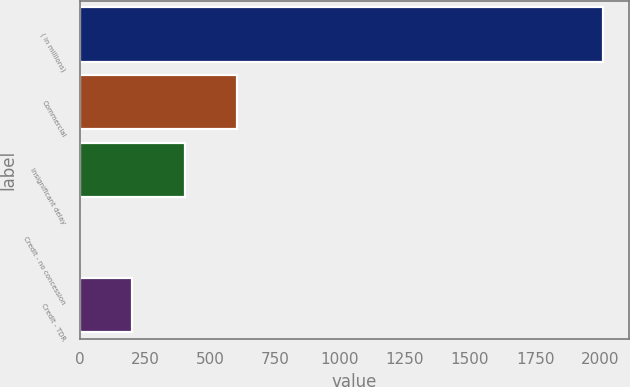Convert chart. <chart><loc_0><loc_0><loc_500><loc_500><bar_chart><fcel>( in millions)<fcel>Commercial<fcel>Insignificant delay<fcel>Credit - no concession<fcel>Credit - TDR<nl><fcel>2012<fcel>604.02<fcel>402.88<fcel>0.6<fcel>201.74<nl></chart> 